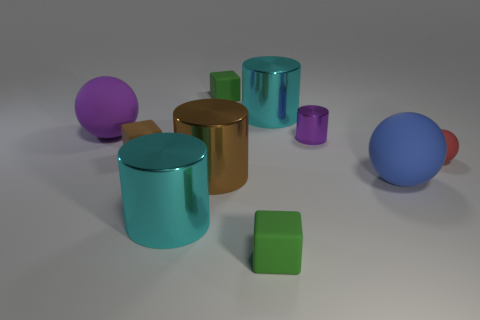Subtract 1 cylinders. How many cylinders are left? 3 Subtract all red cylinders. Subtract all yellow spheres. How many cylinders are left? 4 Subtract all cylinders. How many objects are left? 6 Add 5 cylinders. How many cylinders are left? 9 Add 6 yellow rubber balls. How many yellow rubber balls exist? 6 Subtract 1 purple spheres. How many objects are left? 9 Subtract all tiny shiny cylinders. Subtract all gray things. How many objects are left? 9 